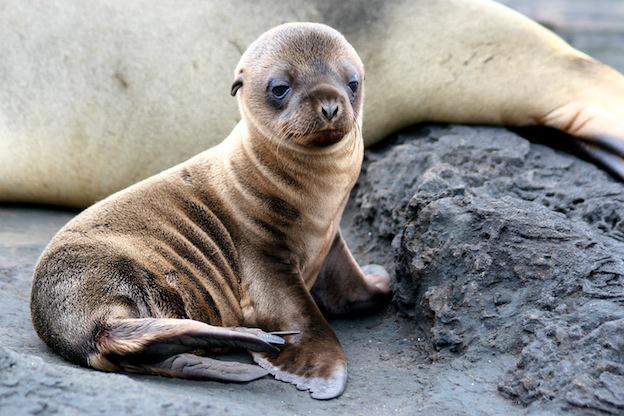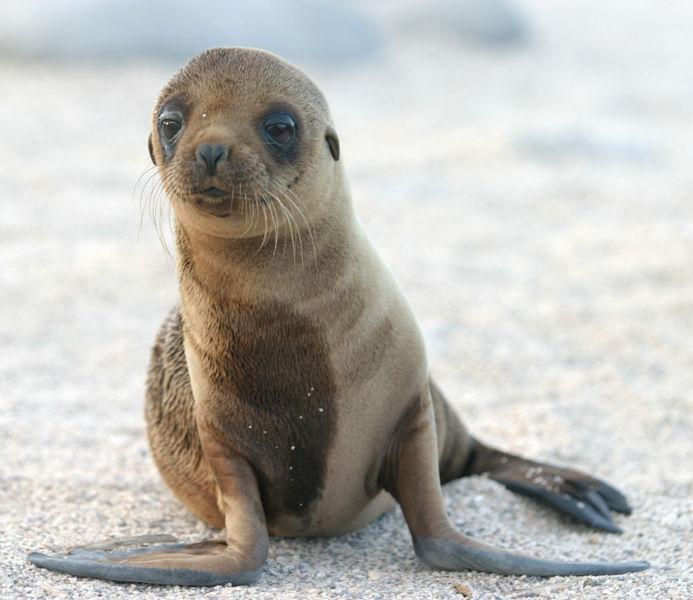The first image is the image on the left, the second image is the image on the right. Considering the images on both sides, is "No image shows more than two seals." valid? Answer yes or no. Yes. 